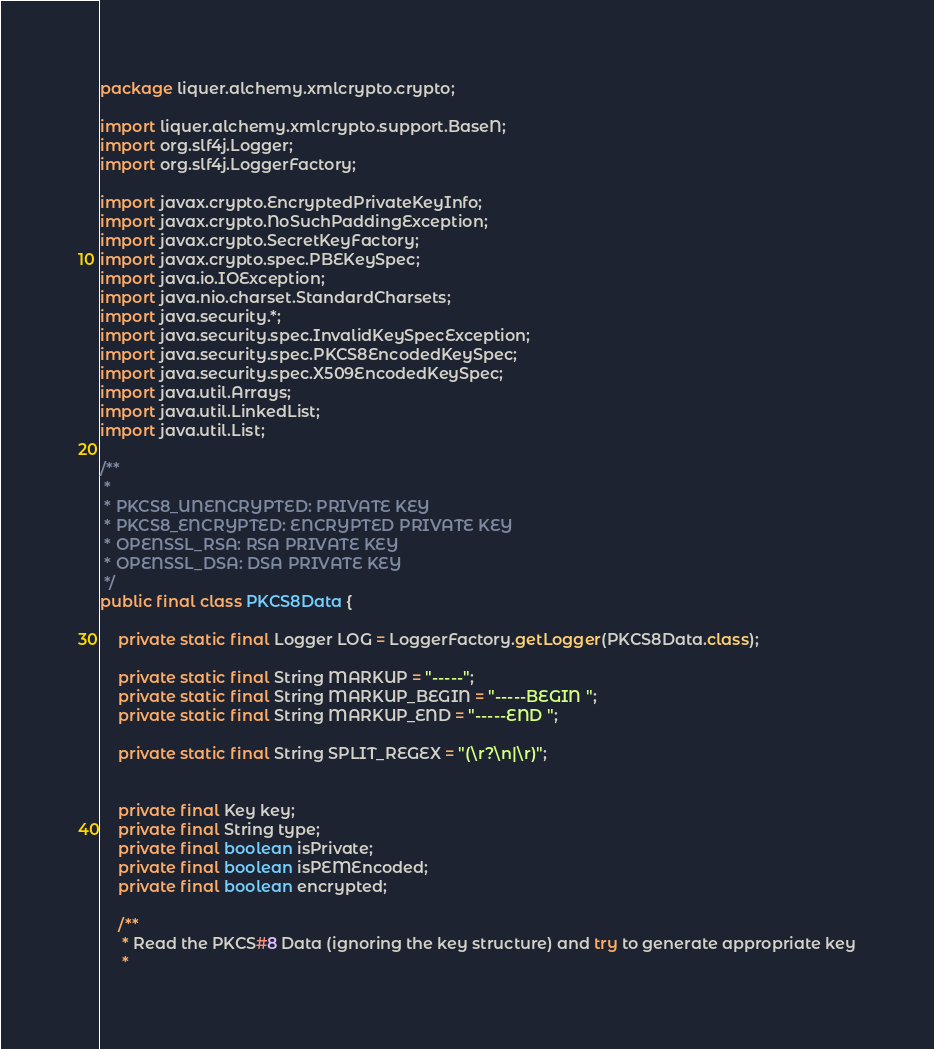<code> <loc_0><loc_0><loc_500><loc_500><_Java_>package liquer.alchemy.xmlcrypto.crypto;

import liquer.alchemy.xmlcrypto.support.BaseN;
import org.slf4j.Logger;
import org.slf4j.LoggerFactory;

import javax.crypto.EncryptedPrivateKeyInfo;
import javax.crypto.NoSuchPaddingException;
import javax.crypto.SecretKeyFactory;
import javax.crypto.spec.PBEKeySpec;
import java.io.IOException;
import java.nio.charset.StandardCharsets;
import java.security.*;
import java.security.spec.InvalidKeySpecException;
import java.security.spec.PKCS8EncodedKeySpec;
import java.security.spec.X509EncodedKeySpec;
import java.util.Arrays;
import java.util.LinkedList;
import java.util.List;

/**
 *
 * PKCS8_UNENCRYPTED: PRIVATE KEY
 * PKCS8_ENCRYPTED: ENCRYPTED PRIVATE KEY
 * OPENSSL_RSA: RSA PRIVATE KEY
 * OPENSSL_DSA: DSA PRIVATE KEY
 */
public final class PKCS8Data {

    private static final Logger LOG = LoggerFactory.getLogger(PKCS8Data.class);

    private static final String MARKUP = "-----";
    private static final String MARKUP_BEGIN = "-----BEGIN ";
    private static final String MARKUP_END = "-----END ";

    private static final String SPLIT_REGEX = "(\r?\n|\r)";


    private final Key key;
    private final String type;
    private final boolean isPrivate;
    private final boolean isPEMEncoded;
    private final boolean encrypted;

    /**
     * Read the PKCS#8 Data (ignoring the key structure) and try to generate appropriate key
     *</code> 